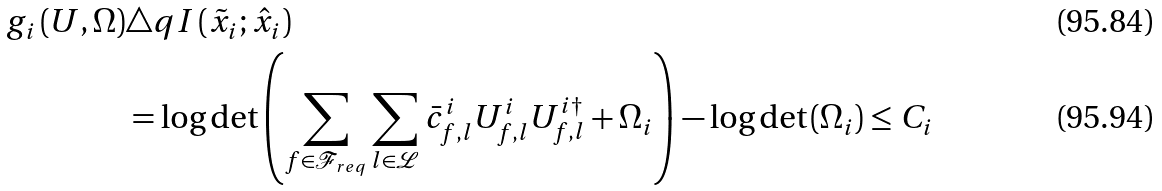Convert formula to latex. <formula><loc_0><loc_0><loc_500><loc_500>g _ { i } \left ( U , \Omega \right ) & \triangle q I \left ( \tilde { x } _ { i } ; \hat { x } _ { i } \right ) \\ & = \log \det \left ( \sum _ { f \in \mathcal { F } _ { r e q } } \sum _ { l \in \mathcal { L } } \bar { c } _ { f , l } ^ { i } U _ { f , l } ^ { i } U _ { f , l } ^ { i \dagger } + \Omega _ { i } \right ) - \log \det \left ( \Omega _ { i } \right ) \leq C _ { i }</formula> 